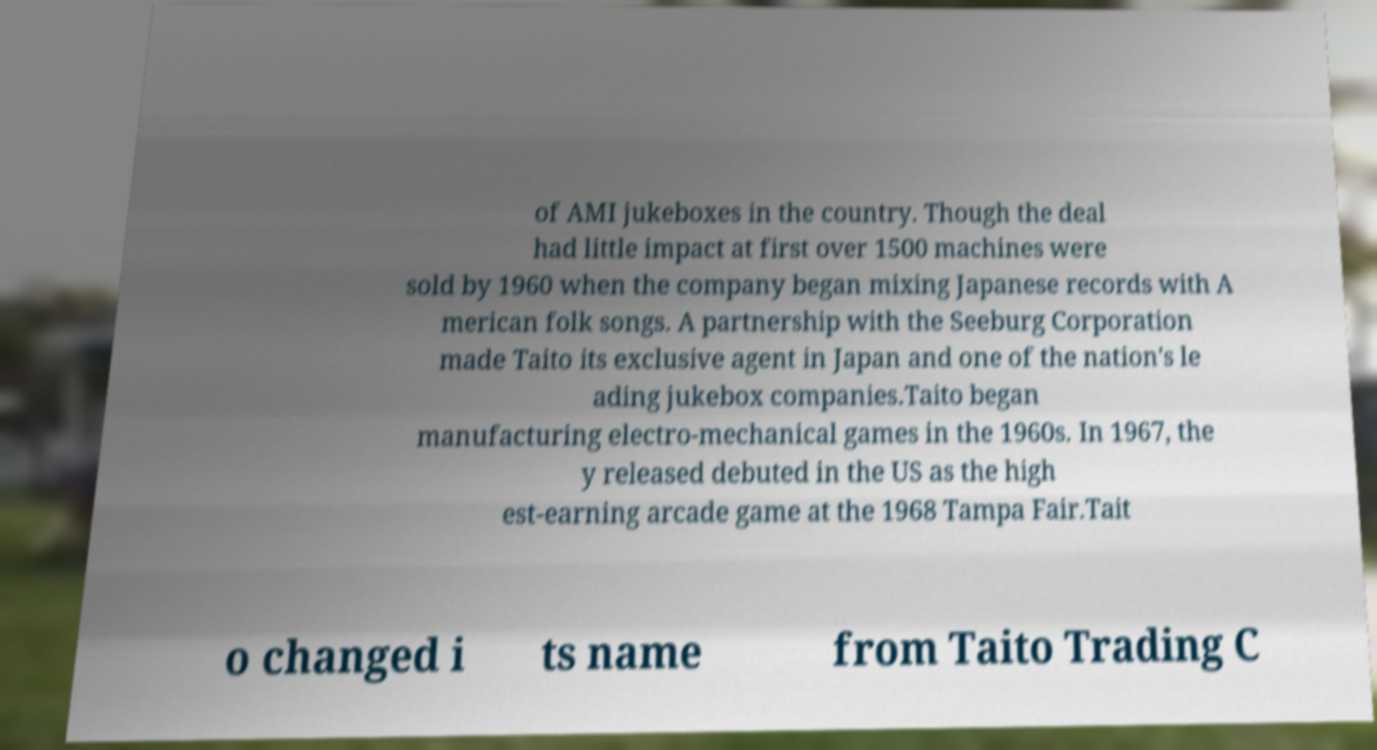Please identify and transcribe the text found in this image. of AMI jukeboxes in the country. Though the deal had little impact at first over 1500 machines were sold by 1960 when the company began mixing Japanese records with A merican folk songs. A partnership with the Seeburg Corporation made Taito its exclusive agent in Japan and one of the nation's le ading jukebox companies.Taito began manufacturing electro-mechanical games in the 1960s. In 1967, the y released debuted in the US as the high est-earning arcade game at the 1968 Tampa Fair.Tait o changed i ts name from Taito Trading C 